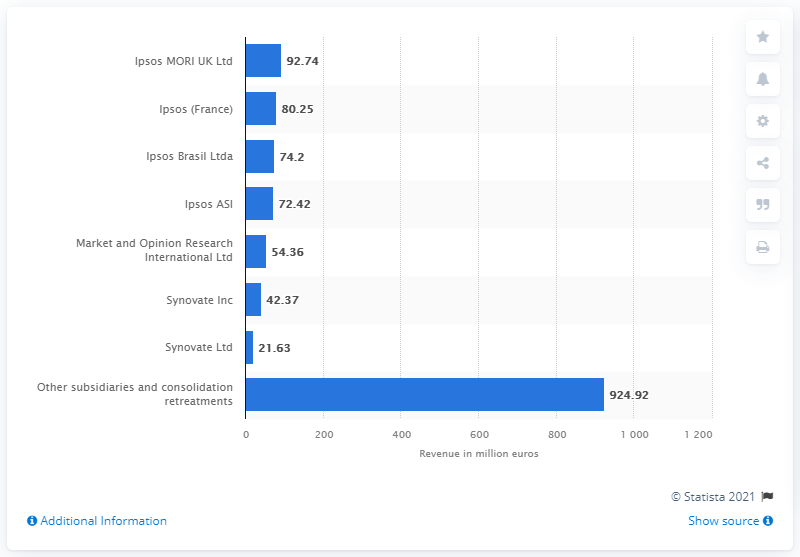Draw attention to some important aspects in this diagram. Ipsos generated 92.74 million in 2011. 